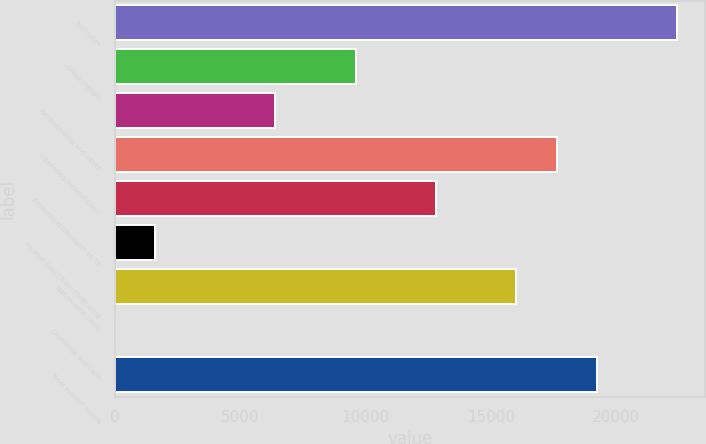<chart> <loc_0><loc_0><loc_500><loc_500><bar_chart><fcel>Net sales<fcel>Gross margin<fcel>Restructuring and other<fcel>Operating income (loss)<fcel>Amounts attributable to TE<fcel>Income (loss) from continuing<fcel>Net income (loss)<fcel>Dividends and cash<fcel>Total current assets<nl><fcel>22425<fcel>9611.08<fcel>6407.6<fcel>17619.8<fcel>12814.6<fcel>1602.38<fcel>16018<fcel>0.64<fcel>19221.5<nl></chart> 